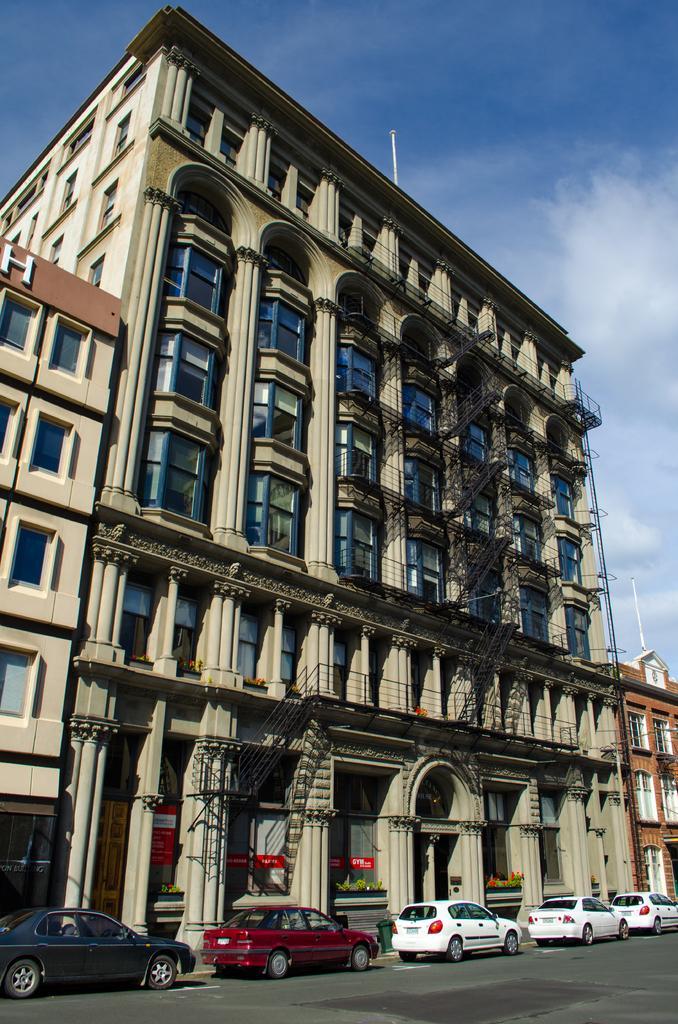Can you describe this image briefly? In this image in the center there are some buildings and also cars, at the bottom there is road and at the top of the image there is sky and also there are some pillars and poles. 